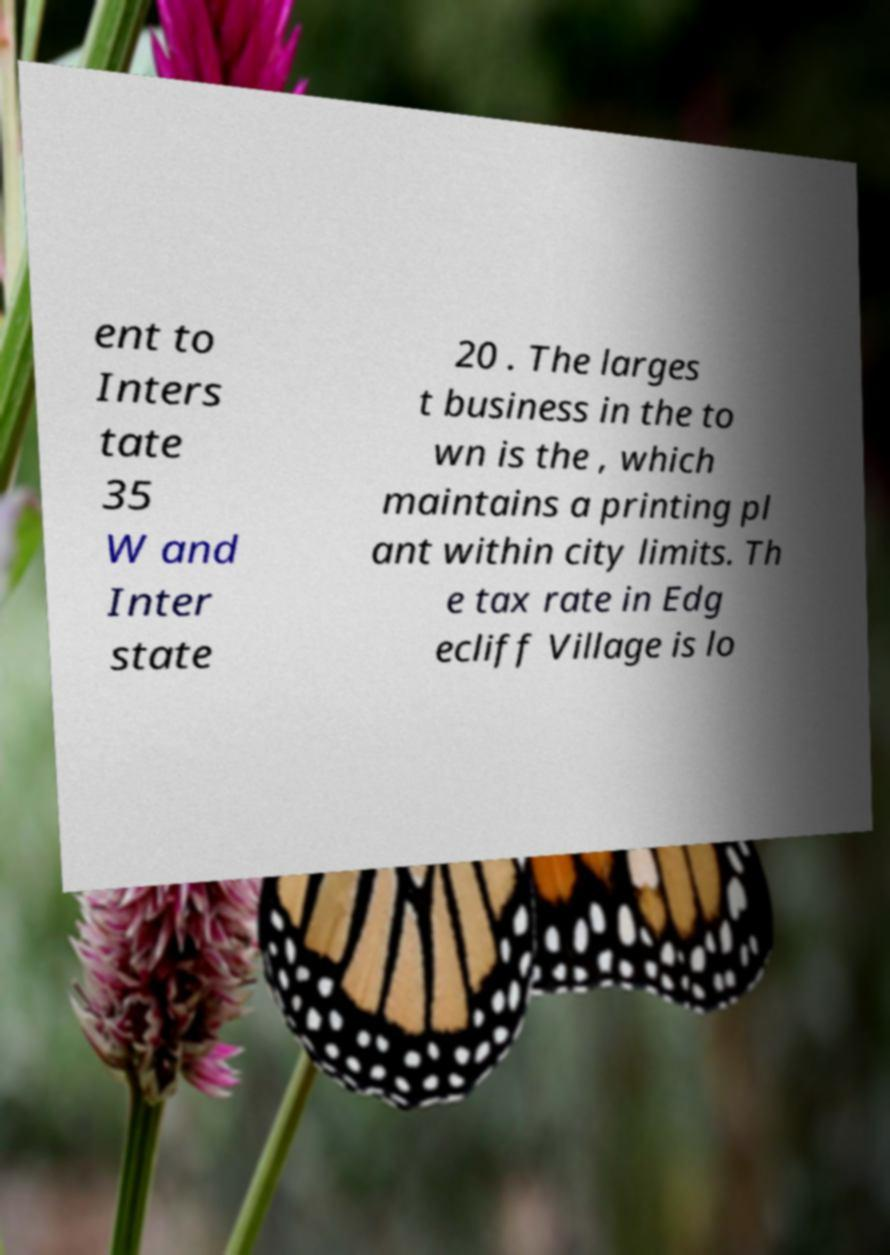There's text embedded in this image that I need extracted. Can you transcribe it verbatim? ent to Inters tate 35 W and Inter state 20 . The larges t business in the to wn is the , which maintains a printing pl ant within city limits. Th e tax rate in Edg ecliff Village is lo 